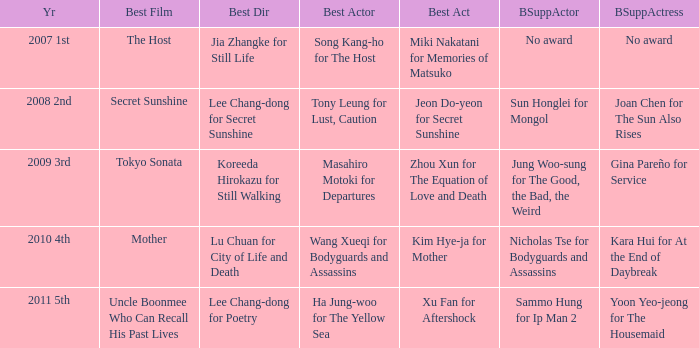Name the best supporting actress for sun honglei for mongol Joan Chen for The Sun Also Rises. 